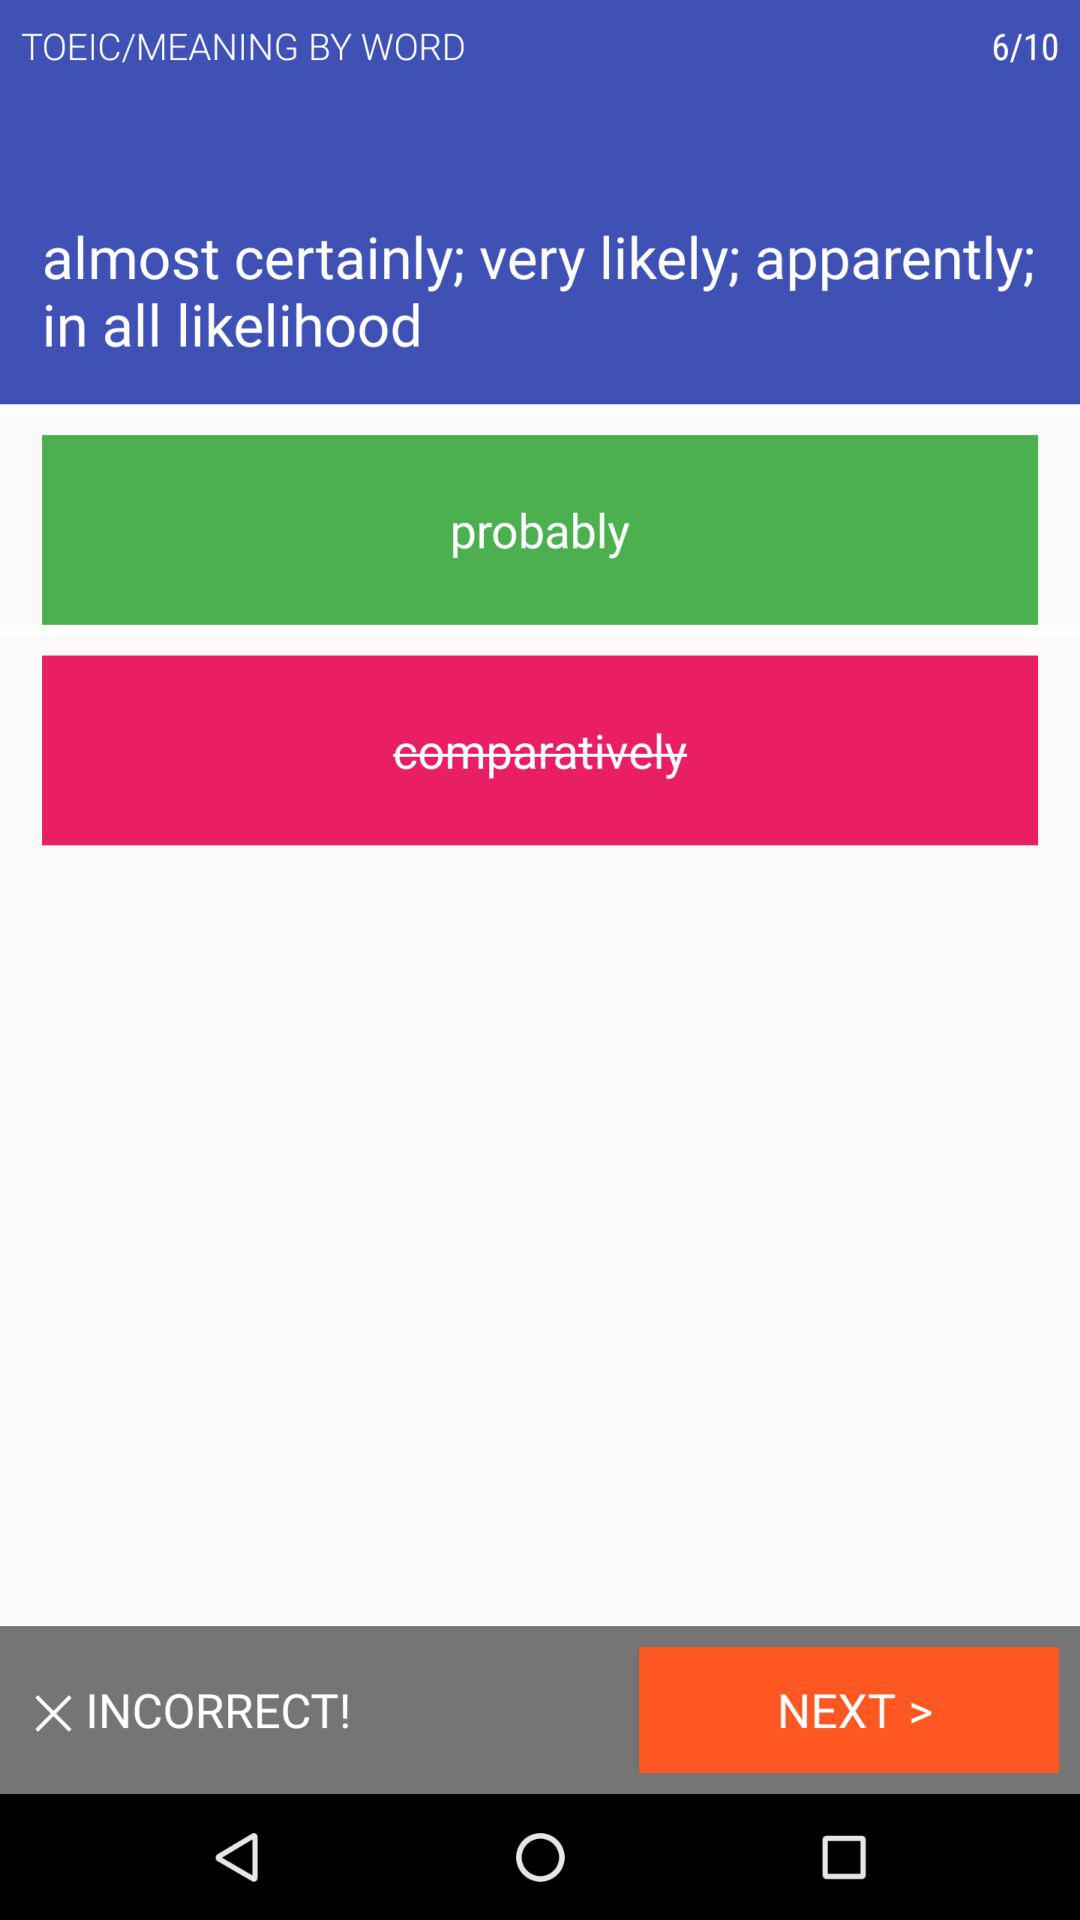Was my answer correct or incorrect? Your answer was incorrect. 